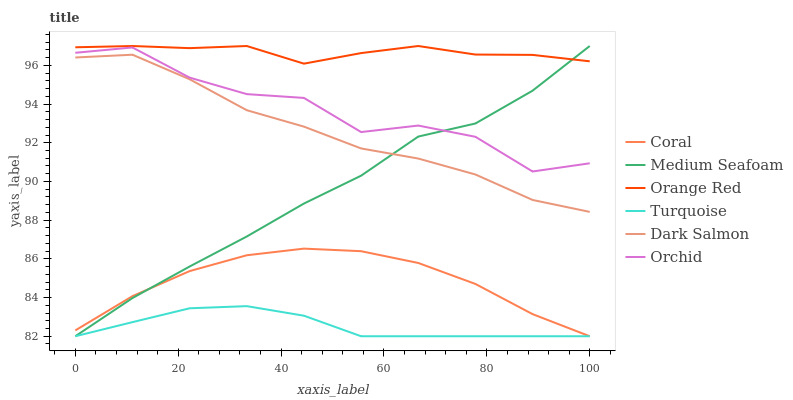Does Turquoise have the minimum area under the curve?
Answer yes or no. Yes. Does Orange Red have the maximum area under the curve?
Answer yes or no. Yes. Does Coral have the minimum area under the curve?
Answer yes or no. No. Does Coral have the maximum area under the curve?
Answer yes or no. No. Is Turquoise the smoothest?
Answer yes or no. Yes. Is Orchid the roughest?
Answer yes or no. Yes. Is Coral the smoothest?
Answer yes or no. No. Is Coral the roughest?
Answer yes or no. No. Does Turquoise have the lowest value?
Answer yes or no. Yes. Does Dark Salmon have the lowest value?
Answer yes or no. No. Does Medium Seafoam have the highest value?
Answer yes or no. Yes. Does Coral have the highest value?
Answer yes or no. No. Is Orchid less than Orange Red?
Answer yes or no. Yes. Is Orchid greater than Coral?
Answer yes or no. Yes. Does Coral intersect Turquoise?
Answer yes or no. Yes. Is Coral less than Turquoise?
Answer yes or no. No. Is Coral greater than Turquoise?
Answer yes or no. No. Does Orchid intersect Orange Red?
Answer yes or no. No. 